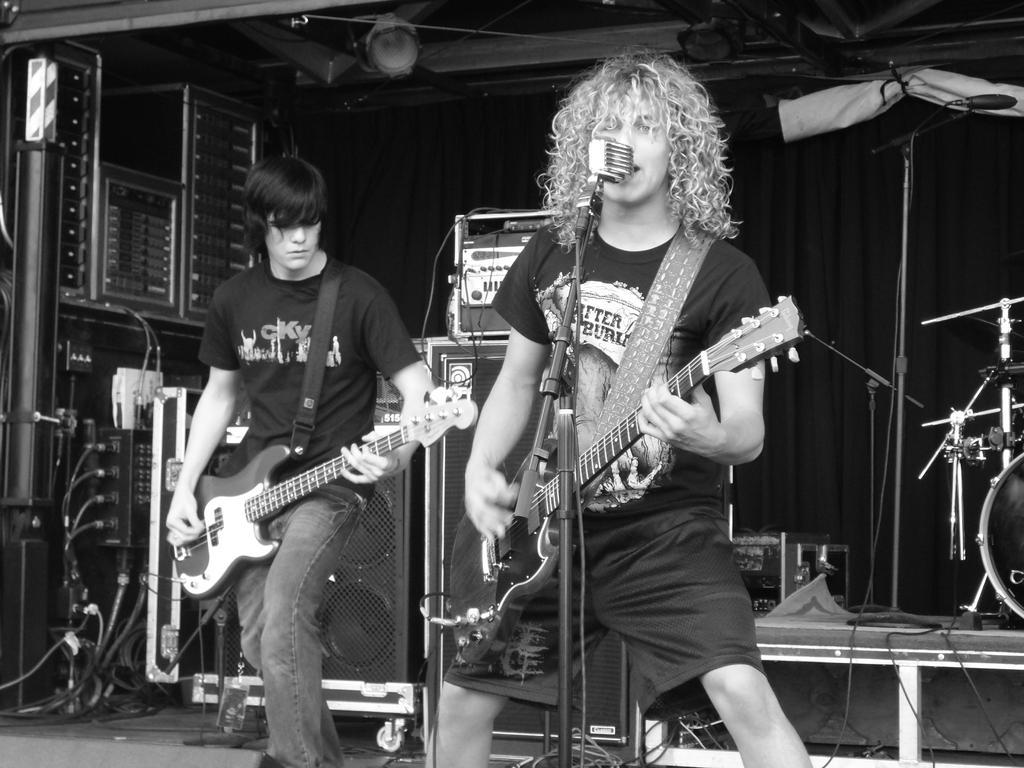Please provide a concise description of this image. These two persons standing and holding guitar. This person singing. There is a microphone with stand. On the background we can see curtain,musical instrument. 